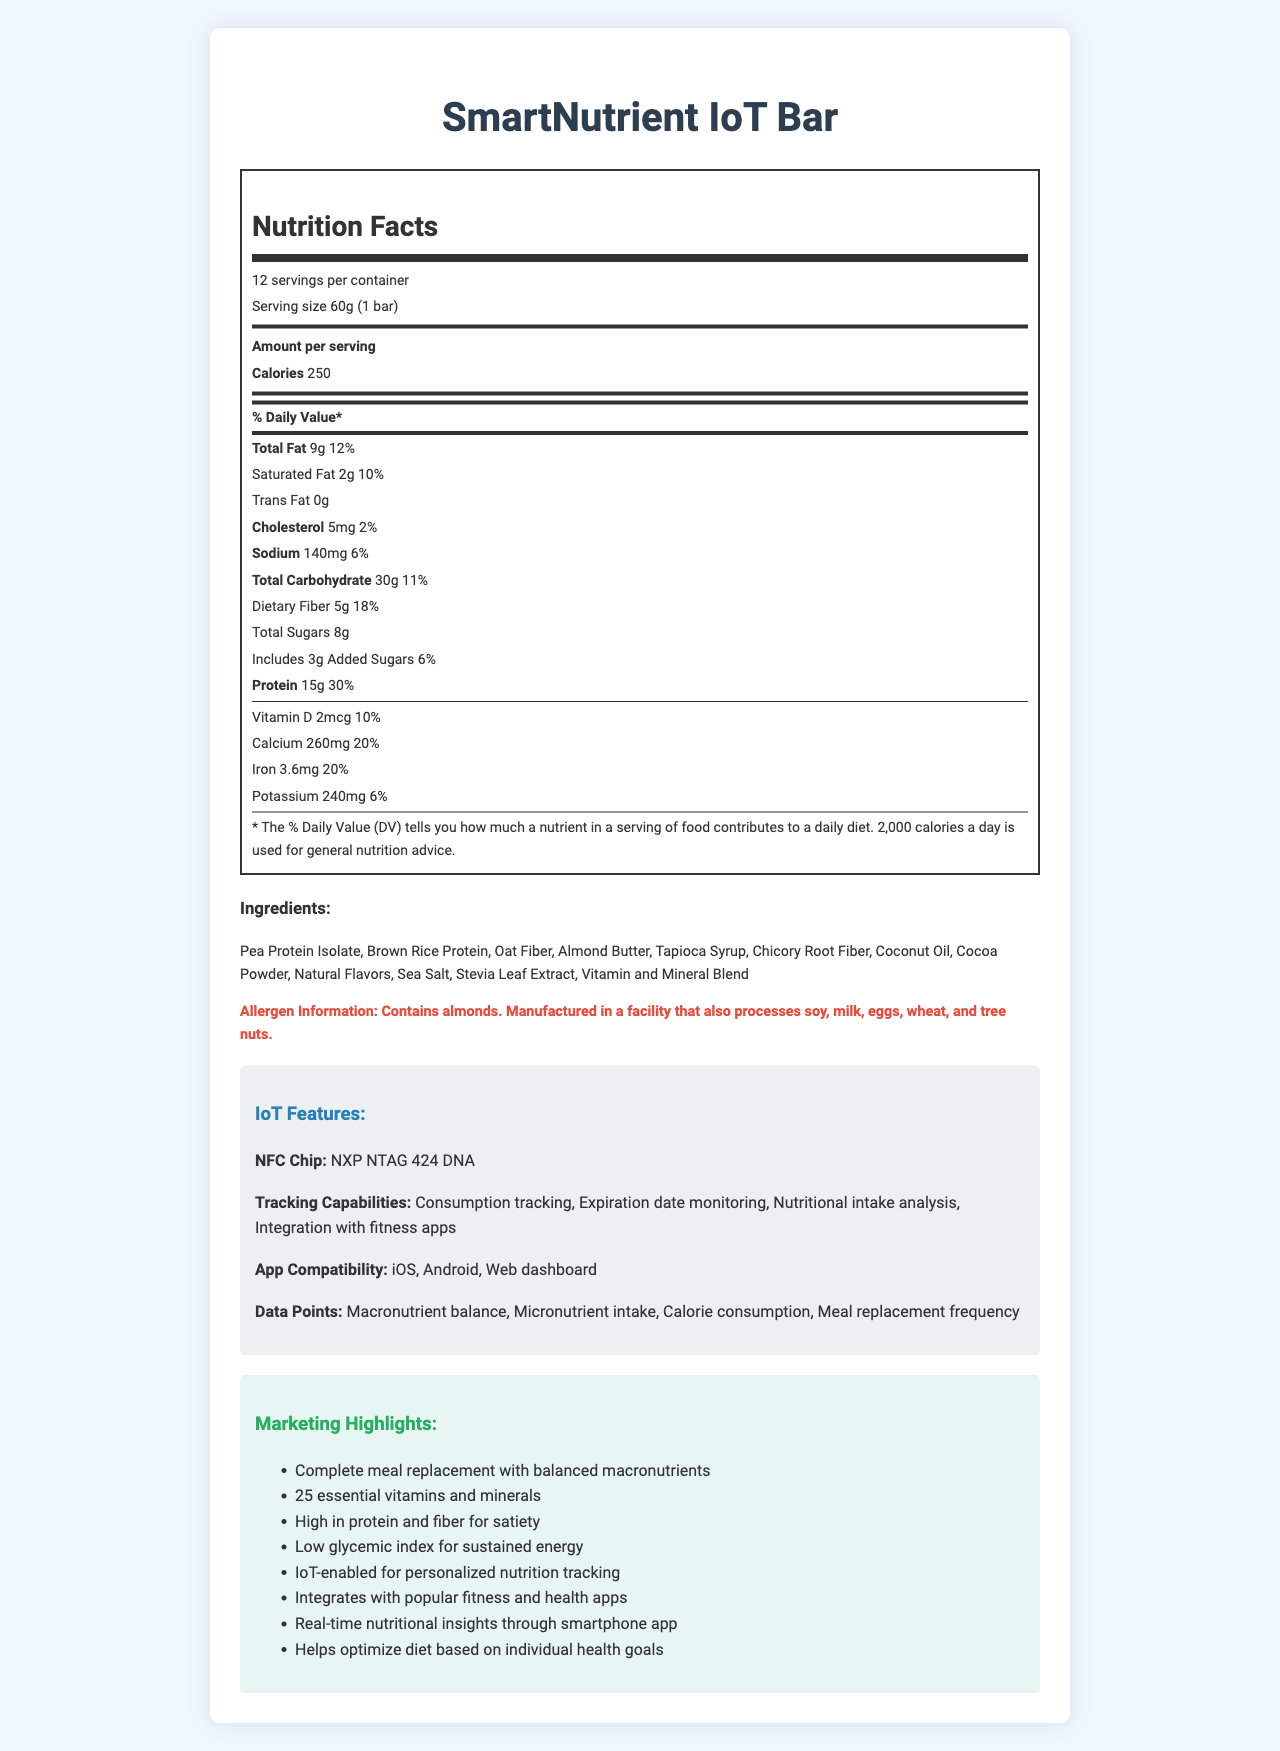What is the serving size of the SmartNutrient IoT Bar? The serving size is mentioned explicitly in the first section of the document.
Answer: 60g (1 bar) How many calories are there per serving? The number of calories per serving is displayed under the "Amount per serving" section.
Answer: 250 Which macronutrient has the highest daily value percentage? Protein has a daily value of 30%, which is the highest among the listed macronutrients.
Answer: Protein What is the total amount of fat per serving? The total fat amount is given in the macronutrients section.
Answer: 9g Does the bar contain any added sugars? The nutrition label mentions 3g of added sugars with a daily value of 6%.
Answer: Yes Which ingredient is explicitly mentioned as a potential allergen? The allergen information states, "Contains almonds."
Answer: Almonds Name three tracking capabilities of the IoT features. The IoT features section lists all the tracking capabilities.
Answer: Consumption tracking, Expiration date monitoring, Nutritional intake analysis How much dietary fiber does the bar contain per serving? The dietary fiber content is listed under the total carbohydrate breakdown.
Answer: 5g What is the daily value percentage of calcium in the SmartNutrient IoT Bar? The percent daily value for calcium is given in the micronutrients section.
Answer: 20% What are the app compatibility options for the SmartNutrient IoT Bar? The document lists these three platforms in the IoT features section.
Answer: iOS, Android, Web dashboard Which feature is NOT a part of the IoT tracking capabilities? A. Meal replacement frequency B. Nutritional intake analysis C. Blood sugar monitoring Blood sugar monitoring is not listed under tracking capabilities.
Answer: C How many grams of protein does the bar provide? A. 10g B. 12g C. 15g D. 20g The document states that the bar provides 15g of protein.
Answer: C Is there any information about the sugar source used in the SmartNutrient IoT Bar? (Yes/No) The document lists the sugar content but not the specific source of the sugars.
Answer: No Which vitamin has the highest daily value percentage in the bar? Thiamin has a daily value of 25%, along with several other B vitamins.
Answer: Thiamin Summarize the main idea of the document. The document provides detailed nutrition facts, ingredients, allergen information, IoT capabilities, and marketing highlights of the SmartNutrient IoT Bar.
Answer: The SmartNutrient IoT Bar is a meal replacement bar that provides a comprehensive nutrition profile, including macronutrients, micronutrients, and IoT features for personalized nutrition tracking. The bar contains 250 calories, 15g of protein, 5g of dietary fiber, and a blend of vitamins and minerals. It also integrates with iOS, Android, and web platforms for consumption tracking, expiration date monitoring, and nutritional analysis. What is the exact percentage daily value of vitamin C? The daily value for vitamin C is listed in the micronutrients section.
Answer: 10% How many servings are there per container? The document states that there are 12 servings per container.
Answer: 12 Describe one of the key marketing highlights of the SmartNutrient IoT Bar. One of the marketing highlights is that the bar is high in protein and fiber, which helps with satiety.
Answer: High in protein and fiber for satiety What is the NFC chip used in the IoT features? The NFC chip used is specifically mentioned in the IoT features section.
Answer: NXP NTAG 424 DNA Which mineral has a daily value percentage of 25%? No mineral listed has a daily value of 25% in the document.
Answer: None 